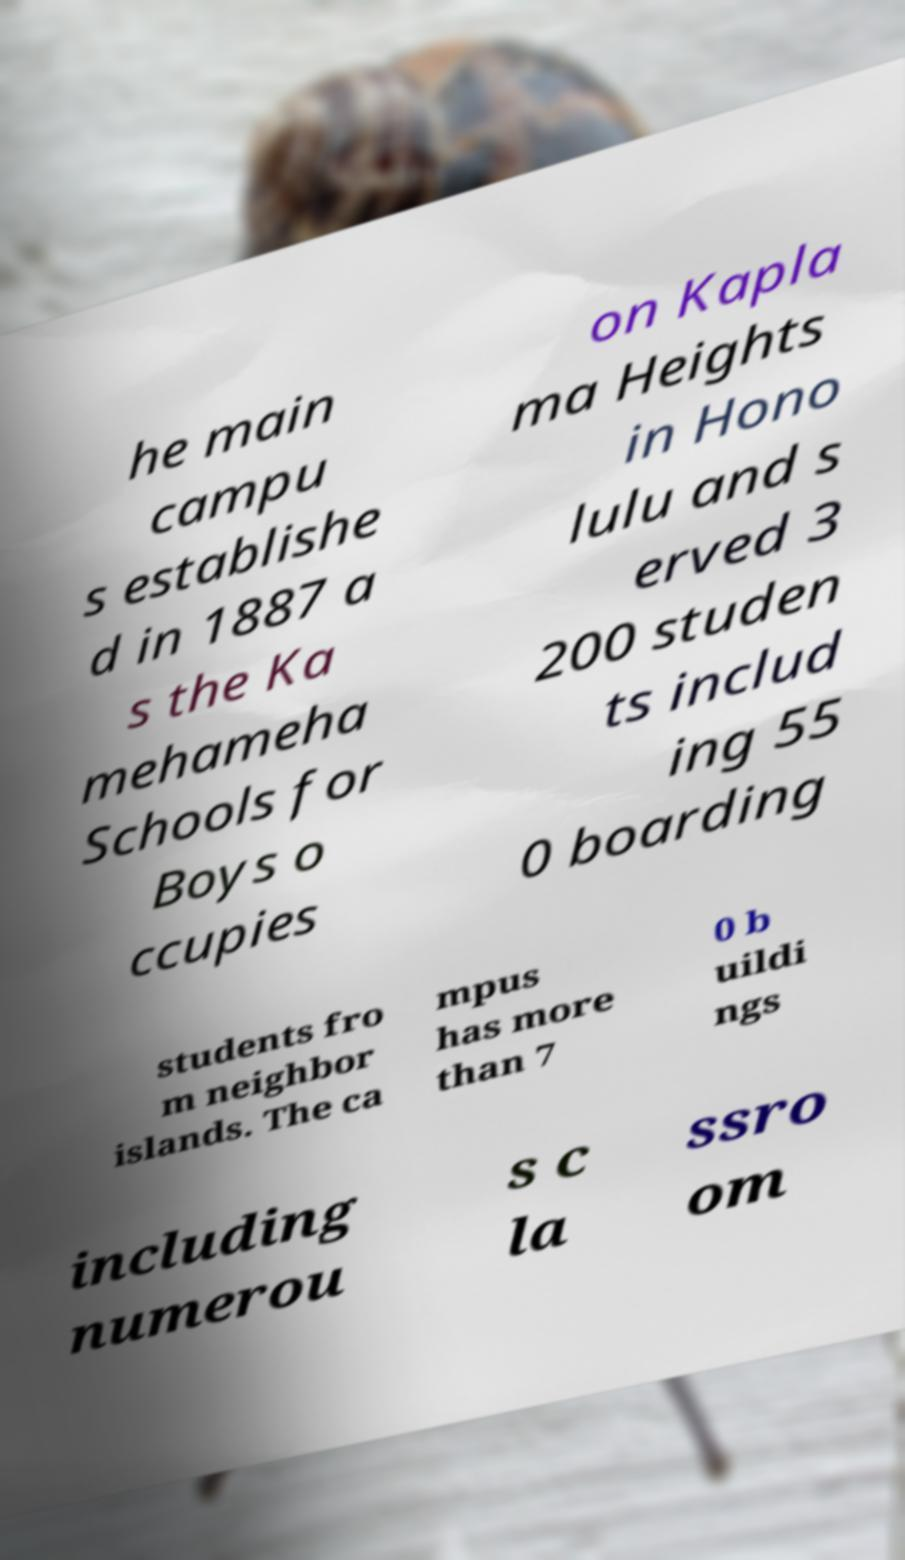Please identify and transcribe the text found in this image. he main campu s establishe d in 1887 a s the Ka mehameha Schools for Boys o ccupies on Kapla ma Heights in Hono lulu and s erved 3 200 studen ts includ ing 55 0 boarding students fro m neighbor islands. The ca mpus has more than 7 0 b uildi ngs including numerou s c la ssro om 